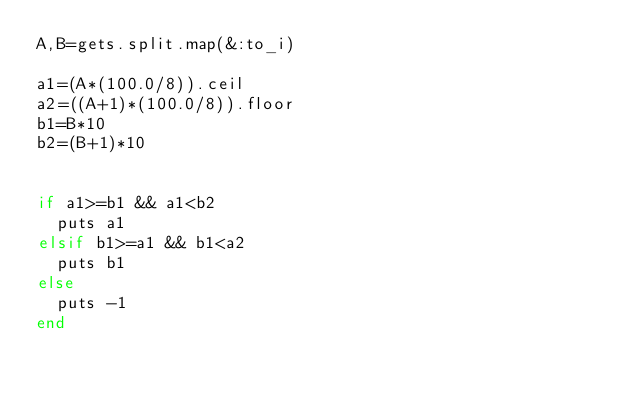<code> <loc_0><loc_0><loc_500><loc_500><_Ruby_>A,B=gets.split.map(&:to_i)

a1=(A*(100.0/8)).ceil
a2=((A+1)*(100.0/8)).floor
b1=B*10
b2=(B+1)*10


if a1>=b1 && a1<b2
  puts a1
elsif b1>=a1 && b1<a2
  puts b1
else
  puts -1
end
</code> 